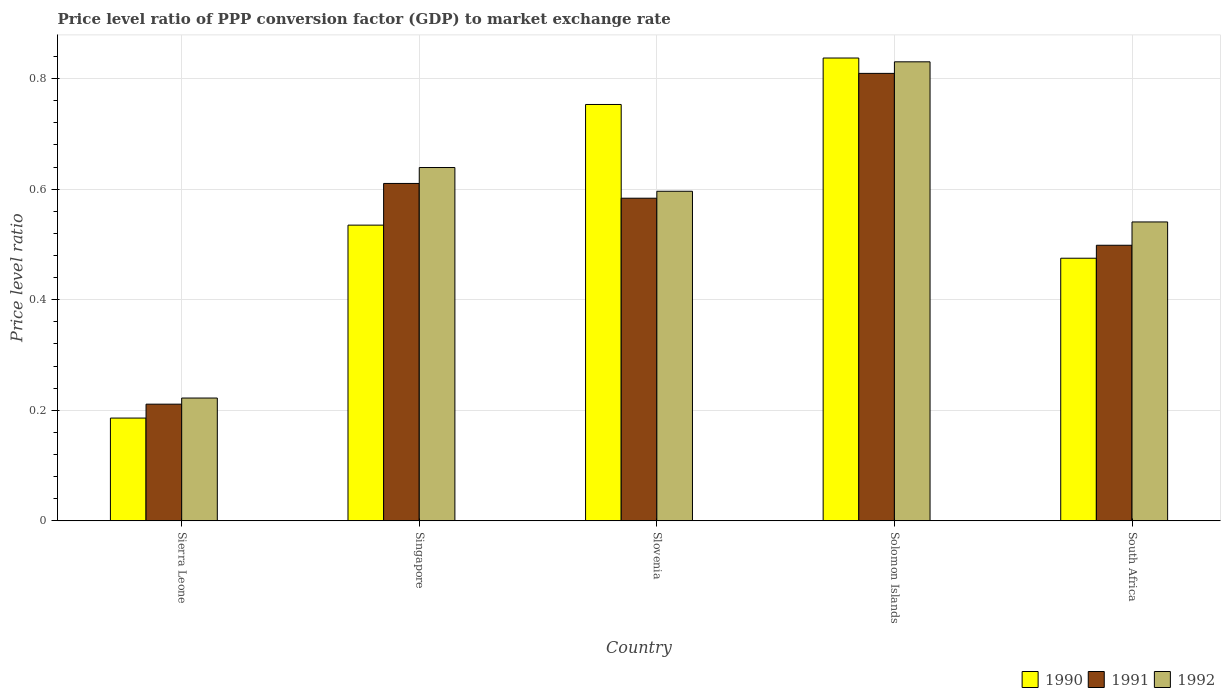How many different coloured bars are there?
Your answer should be compact. 3. How many groups of bars are there?
Ensure brevity in your answer.  5. Are the number of bars per tick equal to the number of legend labels?
Offer a very short reply. Yes. Are the number of bars on each tick of the X-axis equal?
Your answer should be compact. Yes. How many bars are there on the 3rd tick from the right?
Provide a short and direct response. 3. What is the label of the 1st group of bars from the left?
Give a very brief answer. Sierra Leone. What is the price level ratio in 1991 in Singapore?
Your response must be concise. 0.61. Across all countries, what is the maximum price level ratio in 1991?
Offer a very short reply. 0.81. Across all countries, what is the minimum price level ratio in 1991?
Your response must be concise. 0.21. In which country was the price level ratio in 1991 maximum?
Make the answer very short. Solomon Islands. In which country was the price level ratio in 1990 minimum?
Make the answer very short. Sierra Leone. What is the total price level ratio in 1990 in the graph?
Offer a terse response. 2.79. What is the difference between the price level ratio in 1991 in Singapore and that in Solomon Islands?
Keep it short and to the point. -0.2. What is the difference between the price level ratio in 1991 in Slovenia and the price level ratio in 1992 in Singapore?
Give a very brief answer. -0.06. What is the average price level ratio in 1992 per country?
Give a very brief answer. 0.57. What is the difference between the price level ratio of/in 1990 and price level ratio of/in 1991 in South Africa?
Give a very brief answer. -0.02. What is the ratio of the price level ratio in 1991 in Slovenia to that in South Africa?
Keep it short and to the point. 1.17. Is the price level ratio in 1991 in Solomon Islands less than that in South Africa?
Provide a short and direct response. No. Is the difference between the price level ratio in 1990 in Sierra Leone and Singapore greater than the difference between the price level ratio in 1991 in Sierra Leone and Singapore?
Your response must be concise. Yes. What is the difference between the highest and the second highest price level ratio in 1992?
Your answer should be compact. 0.19. What is the difference between the highest and the lowest price level ratio in 1990?
Make the answer very short. 0.65. What does the 1st bar from the left in Singapore represents?
Provide a short and direct response. 1990. What does the 1st bar from the right in South Africa represents?
Your response must be concise. 1992. Is it the case that in every country, the sum of the price level ratio in 1990 and price level ratio in 1991 is greater than the price level ratio in 1992?
Your answer should be very brief. Yes. Are all the bars in the graph horizontal?
Your answer should be very brief. No. What is the difference between two consecutive major ticks on the Y-axis?
Ensure brevity in your answer.  0.2. Where does the legend appear in the graph?
Your answer should be compact. Bottom right. What is the title of the graph?
Offer a terse response. Price level ratio of PPP conversion factor (GDP) to market exchange rate. What is the label or title of the Y-axis?
Ensure brevity in your answer.  Price level ratio. What is the Price level ratio in 1990 in Sierra Leone?
Provide a succinct answer. 0.19. What is the Price level ratio in 1991 in Sierra Leone?
Provide a short and direct response. 0.21. What is the Price level ratio in 1992 in Sierra Leone?
Your response must be concise. 0.22. What is the Price level ratio in 1990 in Singapore?
Offer a terse response. 0.53. What is the Price level ratio of 1991 in Singapore?
Give a very brief answer. 0.61. What is the Price level ratio of 1992 in Singapore?
Provide a short and direct response. 0.64. What is the Price level ratio in 1990 in Slovenia?
Offer a very short reply. 0.75. What is the Price level ratio of 1991 in Slovenia?
Your response must be concise. 0.58. What is the Price level ratio of 1992 in Slovenia?
Keep it short and to the point. 0.6. What is the Price level ratio of 1990 in Solomon Islands?
Make the answer very short. 0.84. What is the Price level ratio in 1991 in Solomon Islands?
Ensure brevity in your answer.  0.81. What is the Price level ratio of 1992 in Solomon Islands?
Your response must be concise. 0.83. What is the Price level ratio of 1990 in South Africa?
Offer a terse response. 0.48. What is the Price level ratio in 1991 in South Africa?
Give a very brief answer. 0.5. What is the Price level ratio in 1992 in South Africa?
Provide a succinct answer. 0.54. Across all countries, what is the maximum Price level ratio of 1990?
Keep it short and to the point. 0.84. Across all countries, what is the maximum Price level ratio in 1991?
Offer a very short reply. 0.81. Across all countries, what is the maximum Price level ratio of 1992?
Your answer should be compact. 0.83. Across all countries, what is the minimum Price level ratio of 1990?
Keep it short and to the point. 0.19. Across all countries, what is the minimum Price level ratio in 1991?
Keep it short and to the point. 0.21. Across all countries, what is the minimum Price level ratio in 1992?
Your answer should be compact. 0.22. What is the total Price level ratio of 1990 in the graph?
Make the answer very short. 2.79. What is the total Price level ratio in 1991 in the graph?
Your answer should be very brief. 2.71. What is the total Price level ratio in 1992 in the graph?
Your answer should be very brief. 2.83. What is the difference between the Price level ratio in 1990 in Sierra Leone and that in Singapore?
Keep it short and to the point. -0.35. What is the difference between the Price level ratio of 1991 in Sierra Leone and that in Singapore?
Make the answer very short. -0.4. What is the difference between the Price level ratio in 1992 in Sierra Leone and that in Singapore?
Ensure brevity in your answer.  -0.42. What is the difference between the Price level ratio of 1990 in Sierra Leone and that in Slovenia?
Give a very brief answer. -0.57. What is the difference between the Price level ratio in 1991 in Sierra Leone and that in Slovenia?
Offer a terse response. -0.37. What is the difference between the Price level ratio in 1992 in Sierra Leone and that in Slovenia?
Your answer should be compact. -0.37. What is the difference between the Price level ratio of 1990 in Sierra Leone and that in Solomon Islands?
Ensure brevity in your answer.  -0.65. What is the difference between the Price level ratio of 1991 in Sierra Leone and that in Solomon Islands?
Your answer should be compact. -0.6. What is the difference between the Price level ratio of 1992 in Sierra Leone and that in Solomon Islands?
Keep it short and to the point. -0.61. What is the difference between the Price level ratio in 1990 in Sierra Leone and that in South Africa?
Your response must be concise. -0.29. What is the difference between the Price level ratio in 1991 in Sierra Leone and that in South Africa?
Ensure brevity in your answer.  -0.29. What is the difference between the Price level ratio of 1992 in Sierra Leone and that in South Africa?
Make the answer very short. -0.32. What is the difference between the Price level ratio in 1990 in Singapore and that in Slovenia?
Keep it short and to the point. -0.22. What is the difference between the Price level ratio in 1991 in Singapore and that in Slovenia?
Offer a very short reply. 0.03. What is the difference between the Price level ratio of 1992 in Singapore and that in Slovenia?
Give a very brief answer. 0.04. What is the difference between the Price level ratio of 1990 in Singapore and that in Solomon Islands?
Keep it short and to the point. -0.3. What is the difference between the Price level ratio of 1991 in Singapore and that in Solomon Islands?
Provide a succinct answer. -0.2. What is the difference between the Price level ratio in 1992 in Singapore and that in Solomon Islands?
Offer a very short reply. -0.19. What is the difference between the Price level ratio of 1990 in Singapore and that in South Africa?
Your answer should be very brief. 0.06. What is the difference between the Price level ratio in 1991 in Singapore and that in South Africa?
Provide a short and direct response. 0.11. What is the difference between the Price level ratio in 1992 in Singapore and that in South Africa?
Your answer should be compact. 0.1. What is the difference between the Price level ratio of 1990 in Slovenia and that in Solomon Islands?
Your answer should be compact. -0.08. What is the difference between the Price level ratio in 1991 in Slovenia and that in Solomon Islands?
Offer a very short reply. -0.23. What is the difference between the Price level ratio of 1992 in Slovenia and that in Solomon Islands?
Provide a succinct answer. -0.23. What is the difference between the Price level ratio in 1990 in Slovenia and that in South Africa?
Provide a succinct answer. 0.28. What is the difference between the Price level ratio of 1991 in Slovenia and that in South Africa?
Your answer should be compact. 0.09. What is the difference between the Price level ratio of 1992 in Slovenia and that in South Africa?
Your answer should be compact. 0.06. What is the difference between the Price level ratio in 1990 in Solomon Islands and that in South Africa?
Offer a very short reply. 0.36. What is the difference between the Price level ratio of 1991 in Solomon Islands and that in South Africa?
Your response must be concise. 0.31. What is the difference between the Price level ratio in 1992 in Solomon Islands and that in South Africa?
Provide a succinct answer. 0.29. What is the difference between the Price level ratio in 1990 in Sierra Leone and the Price level ratio in 1991 in Singapore?
Offer a very short reply. -0.42. What is the difference between the Price level ratio in 1990 in Sierra Leone and the Price level ratio in 1992 in Singapore?
Provide a succinct answer. -0.45. What is the difference between the Price level ratio in 1991 in Sierra Leone and the Price level ratio in 1992 in Singapore?
Provide a short and direct response. -0.43. What is the difference between the Price level ratio in 1990 in Sierra Leone and the Price level ratio in 1991 in Slovenia?
Offer a terse response. -0.4. What is the difference between the Price level ratio of 1990 in Sierra Leone and the Price level ratio of 1992 in Slovenia?
Keep it short and to the point. -0.41. What is the difference between the Price level ratio in 1991 in Sierra Leone and the Price level ratio in 1992 in Slovenia?
Ensure brevity in your answer.  -0.39. What is the difference between the Price level ratio in 1990 in Sierra Leone and the Price level ratio in 1991 in Solomon Islands?
Give a very brief answer. -0.62. What is the difference between the Price level ratio in 1990 in Sierra Leone and the Price level ratio in 1992 in Solomon Islands?
Your answer should be very brief. -0.64. What is the difference between the Price level ratio in 1991 in Sierra Leone and the Price level ratio in 1992 in Solomon Islands?
Your response must be concise. -0.62. What is the difference between the Price level ratio in 1990 in Sierra Leone and the Price level ratio in 1991 in South Africa?
Offer a terse response. -0.31. What is the difference between the Price level ratio of 1990 in Sierra Leone and the Price level ratio of 1992 in South Africa?
Provide a short and direct response. -0.35. What is the difference between the Price level ratio in 1991 in Sierra Leone and the Price level ratio in 1992 in South Africa?
Offer a very short reply. -0.33. What is the difference between the Price level ratio of 1990 in Singapore and the Price level ratio of 1991 in Slovenia?
Provide a short and direct response. -0.05. What is the difference between the Price level ratio of 1990 in Singapore and the Price level ratio of 1992 in Slovenia?
Ensure brevity in your answer.  -0.06. What is the difference between the Price level ratio of 1991 in Singapore and the Price level ratio of 1992 in Slovenia?
Provide a short and direct response. 0.01. What is the difference between the Price level ratio of 1990 in Singapore and the Price level ratio of 1991 in Solomon Islands?
Offer a terse response. -0.27. What is the difference between the Price level ratio of 1990 in Singapore and the Price level ratio of 1992 in Solomon Islands?
Offer a terse response. -0.3. What is the difference between the Price level ratio of 1991 in Singapore and the Price level ratio of 1992 in Solomon Islands?
Provide a succinct answer. -0.22. What is the difference between the Price level ratio in 1990 in Singapore and the Price level ratio in 1991 in South Africa?
Keep it short and to the point. 0.04. What is the difference between the Price level ratio of 1990 in Singapore and the Price level ratio of 1992 in South Africa?
Your answer should be compact. -0.01. What is the difference between the Price level ratio in 1991 in Singapore and the Price level ratio in 1992 in South Africa?
Make the answer very short. 0.07. What is the difference between the Price level ratio of 1990 in Slovenia and the Price level ratio of 1991 in Solomon Islands?
Offer a very short reply. -0.06. What is the difference between the Price level ratio in 1990 in Slovenia and the Price level ratio in 1992 in Solomon Islands?
Offer a very short reply. -0.08. What is the difference between the Price level ratio in 1991 in Slovenia and the Price level ratio in 1992 in Solomon Islands?
Provide a short and direct response. -0.25. What is the difference between the Price level ratio in 1990 in Slovenia and the Price level ratio in 1991 in South Africa?
Provide a short and direct response. 0.25. What is the difference between the Price level ratio in 1990 in Slovenia and the Price level ratio in 1992 in South Africa?
Your answer should be very brief. 0.21. What is the difference between the Price level ratio of 1991 in Slovenia and the Price level ratio of 1992 in South Africa?
Your answer should be compact. 0.04. What is the difference between the Price level ratio in 1990 in Solomon Islands and the Price level ratio in 1991 in South Africa?
Your answer should be compact. 0.34. What is the difference between the Price level ratio of 1990 in Solomon Islands and the Price level ratio of 1992 in South Africa?
Your answer should be very brief. 0.3. What is the difference between the Price level ratio in 1991 in Solomon Islands and the Price level ratio in 1992 in South Africa?
Keep it short and to the point. 0.27. What is the average Price level ratio of 1990 per country?
Your answer should be compact. 0.56. What is the average Price level ratio in 1991 per country?
Your answer should be compact. 0.54. What is the average Price level ratio of 1992 per country?
Give a very brief answer. 0.57. What is the difference between the Price level ratio of 1990 and Price level ratio of 1991 in Sierra Leone?
Offer a terse response. -0.03. What is the difference between the Price level ratio of 1990 and Price level ratio of 1992 in Sierra Leone?
Provide a short and direct response. -0.04. What is the difference between the Price level ratio of 1991 and Price level ratio of 1992 in Sierra Leone?
Offer a terse response. -0.01. What is the difference between the Price level ratio in 1990 and Price level ratio in 1991 in Singapore?
Offer a very short reply. -0.08. What is the difference between the Price level ratio of 1990 and Price level ratio of 1992 in Singapore?
Offer a very short reply. -0.1. What is the difference between the Price level ratio in 1991 and Price level ratio in 1992 in Singapore?
Provide a succinct answer. -0.03. What is the difference between the Price level ratio of 1990 and Price level ratio of 1991 in Slovenia?
Keep it short and to the point. 0.17. What is the difference between the Price level ratio in 1990 and Price level ratio in 1992 in Slovenia?
Provide a succinct answer. 0.16. What is the difference between the Price level ratio of 1991 and Price level ratio of 1992 in Slovenia?
Make the answer very short. -0.01. What is the difference between the Price level ratio in 1990 and Price level ratio in 1991 in Solomon Islands?
Ensure brevity in your answer.  0.03. What is the difference between the Price level ratio of 1990 and Price level ratio of 1992 in Solomon Islands?
Your answer should be compact. 0.01. What is the difference between the Price level ratio in 1991 and Price level ratio in 1992 in Solomon Islands?
Provide a succinct answer. -0.02. What is the difference between the Price level ratio of 1990 and Price level ratio of 1991 in South Africa?
Ensure brevity in your answer.  -0.02. What is the difference between the Price level ratio of 1990 and Price level ratio of 1992 in South Africa?
Keep it short and to the point. -0.07. What is the difference between the Price level ratio in 1991 and Price level ratio in 1992 in South Africa?
Make the answer very short. -0.04. What is the ratio of the Price level ratio of 1990 in Sierra Leone to that in Singapore?
Your answer should be very brief. 0.35. What is the ratio of the Price level ratio in 1991 in Sierra Leone to that in Singapore?
Your answer should be compact. 0.35. What is the ratio of the Price level ratio of 1992 in Sierra Leone to that in Singapore?
Offer a very short reply. 0.35. What is the ratio of the Price level ratio in 1990 in Sierra Leone to that in Slovenia?
Make the answer very short. 0.25. What is the ratio of the Price level ratio in 1991 in Sierra Leone to that in Slovenia?
Your answer should be very brief. 0.36. What is the ratio of the Price level ratio of 1992 in Sierra Leone to that in Slovenia?
Provide a succinct answer. 0.37. What is the ratio of the Price level ratio in 1990 in Sierra Leone to that in Solomon Islands?
Offer a very short reply. 0.22. What is the ratio of the Price level ratio in 1991 in Sierra Leone to that in Solomon Islands?
Ensure brevity in your answer.  0.26. What is the ratio of the Price level ratio in 1992 in Sierra Leone to that in Solomon Islands?
Offer a very short reply. 0.27. What is the ratio of the Price level ratio of 1990 in Sierra Leone to that in South Africa?
Your response must be concise. 0.39. What is the ratio of the Price level ratio in 1991 in Sierra Leone to that in South Africa?
Make the answer very short. 0.42. What is the ratio of the Price level ratio in 1992 in Sierra Leone to that in South Africa?
Offer a very short reply. 0.41. What is the ratio of the Price level ratio in 1990 in Singapore to that in Slovenia?
Your answer should be very brief. 0.71. What is the ratio of the Price level ratio of 1991 in Singapore to that in Slovenia?
Give a very brief answer. 1.05. What is the ratio of the Price level ratio of 1992 in Singapore to that in Slovenia?
Give a very brief answer. 1.07. What is the ratio of the Price level ratio of 1990 in Singapore to that in Solomon Islands?
Offer a very short reply. 0.64. What is the ratio of the Price level ratio in 1991 in Singapore to that in Solomon Islands?
Provide a succinct answer. 0.75. What is the ratio of the Price level ratio in 1992 in Singapore to that in Solomon Islands?
Your answer should be compact. 0.77. What is the ratio of the Price level ratio of 1990 in Singapore to that in South Africa?
Offer a very short reply. 1.13. What is the ratio of the Price level ratio of 1991 in Singapore to that in South Africa?
Make the answer very short. 1.22. What is the ratio of the Price level ratio in 1992 in Singapore to that in South Africa?
Ensure brevity in your answer.  1.18. What is the ratio of the Price level ratio in 1990 in Slovenia to that in Solomon Islands?
Offer a terse response. 0.9. What is the ratio of the Price level ratio in 1991 in Slovenia to that in Solomon Islands?
Provide a succinct answer. 0.72. What is the ratio of the Price level ratio in 1992 in Slovenia to that in Solomon Islands?
Your answer should be compact. 0.72. What is the ratio of the Price level ratio in 1990 in Slovenia to that in South Africa?
Provide a succinct answer. 1.59. What is the ratio of the Price level ratio in 1991 in Slovenia to that in South Africa?
Provide a succinct answer. 1.17. What is the ratio of the Price level ratio in 1992 in Slovenia to that in South Africa?
Offer a very short reply. 1.1. What is the ratio of the Price level ratio in 1990 in Solomon Islands to that in South Africa?
Your answer should be compact. 1.76. What is the ratio of the Price level ratio of 1991 in Solomon Islands to that in South Africa?
Provide a succinct answer. 1.62. What is the ratio of the Price level ratio in 1992 in Solomon Islands to that in South Africa?
Your answer should be very brief. 1.54. What is the difference between the highest and the second highest Price level ratio in 1990?
Offer a terse response. 0.08. What is the difference between the highest and the second highest Price level ratio of 1991?
Provide a succinct answer. 0.2. What is the difference between the highest and the second highest Price level ratio in 1992?
Your response must be concise. 0.19. What is the difference between the highest and the lowest Price level ratio in 1990?
Offer a terse response. 0.65. What is the difference between the highest and the lowest Price level ratio in 1991?
Keep it short and to the point. 0.6. What is the difference between the highest and the lowest Price level ratio in 1992?
Your response must be concise. 0.61. 